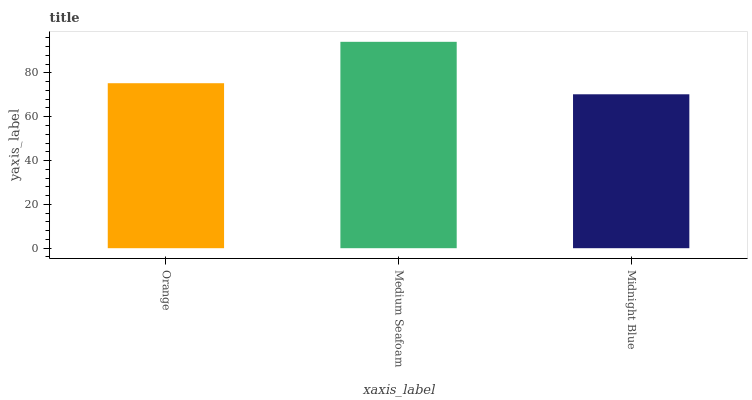Is Midnight Blue the minimum?
Answer yes or no. Yes. Is Medium Seafoam the maximum?
Answer yes or no. Yes. Is Medium Seafoam the minimum?
Answer yes or no. No. Is Midnight Blue the maximum?
Answer yes or no. No. Is Medium Seafoam greater than Midnight Blue?
Answer yes or no. Yes. Is Midnight Blue less than Medium Seafoam?
Answer yes or no. Yes. Is Midnight Blue greater than Medium Seafoam?
Answer yes or no. No. Is Medium Seafoam less than Midnight Blue?
Answer yes or no. No. Is Orange the high median?
Answer yes or no. Yes. Is Orange the low median?
Answer yes or no. Yes. Is Midnight Blue the high median?
Answer yes or no. No. Is Medium Seafoam the low median?
Answer yes or no. No. 